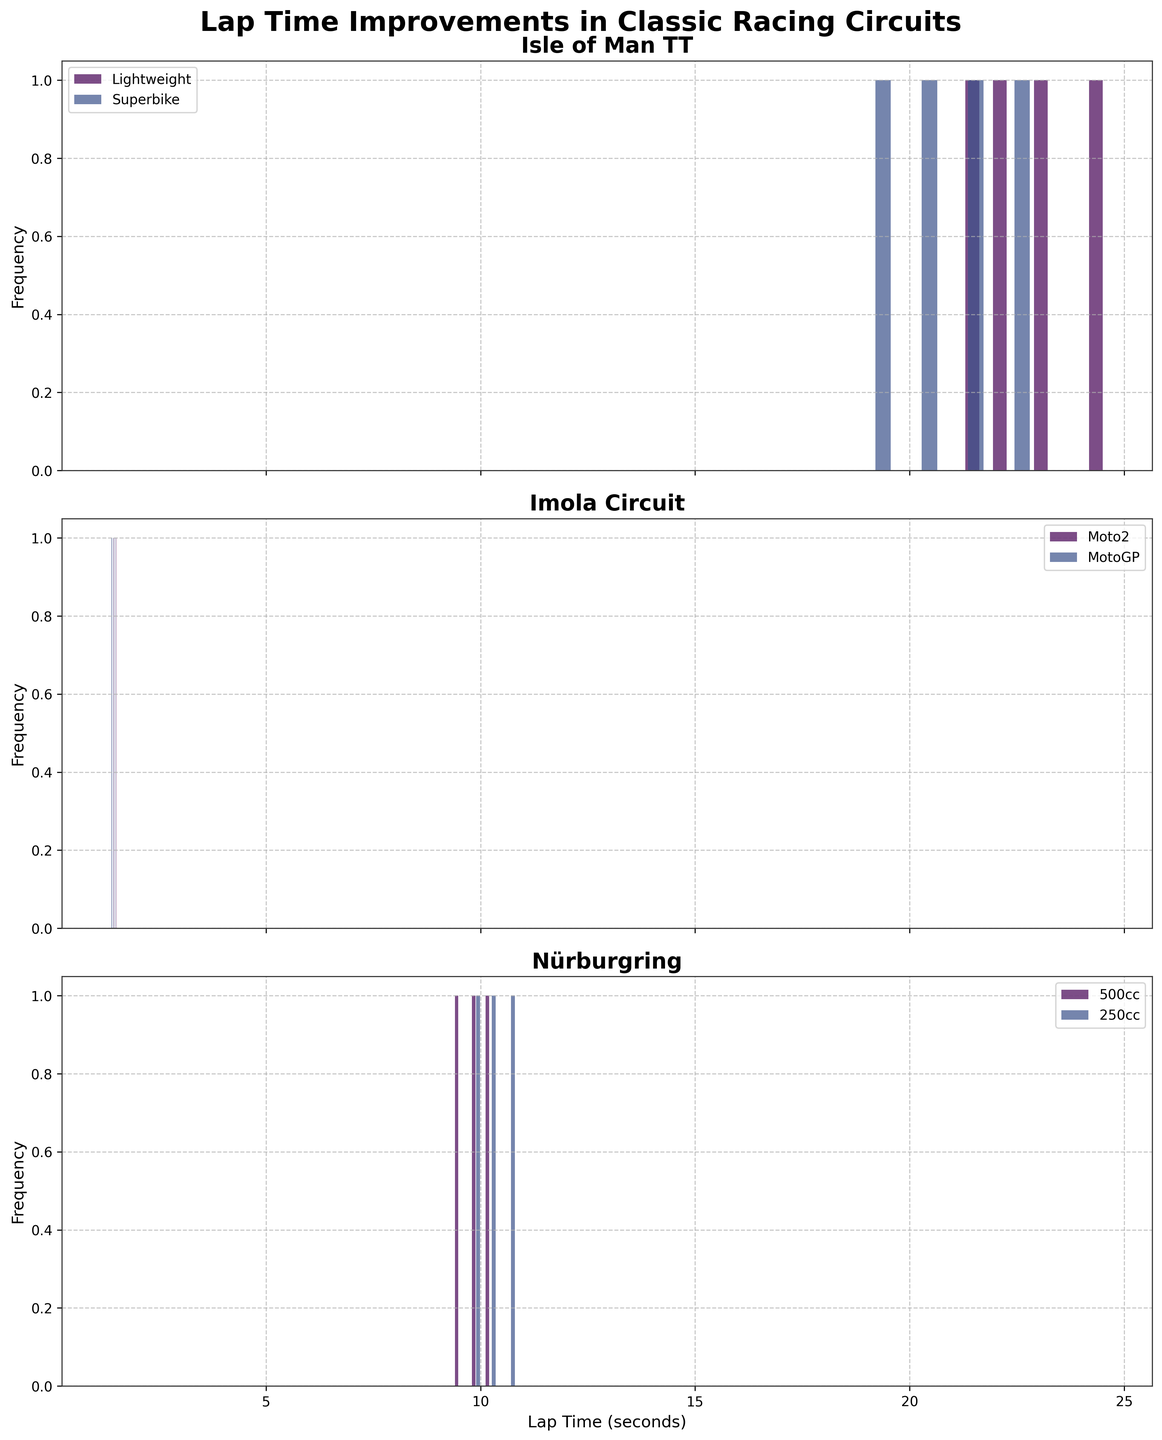What is the title of the figure? The title of the figure is written at the top of the plot. It reads "Lap Time Improvements in Classic Racing Circuits."
Answer: Lap Time Improvements in Classic Racing Circuits How many subplots are there in the figure? The number of subplots can be identified by counting the individual sections or panels within the figure. The data suggests there are three unique circuits, so there should be three subplots.
Answer: 3 Which class has the fastest lap time in the Isle of Man TT circuit? To find the fastest lap time for the Isle of Man TT circuit, look through the histogram for the smallest value on the x-axis. For the Isle of Man TT subplot, the Superbike class shows the fastest lap time.
Answer: Superbike Which circuit has the most classes represented in the subplot? This can be determined by checking how many unique classes are present in each subplot. The Isle of Man TT plot has Lightweight and Superbike, Imola Circuit has Moto2 and MotoGP, while Nürburgring has 500cc and 250cc. They all have two classes each.
Answer: All circuits have 2 classes What is the range of years depicted in the Isle of Man TT circuit? Review the x-axis labels and the bins in the histogram to find the range of years. For the Isle of Man TT circuit, the years range from 1960 to 1990.
Answer: 1960 to 1990 Which class in the Imola Circuit had the greatest improvement in lap times? Compare the differences in lap times for each class in the Imola Circuit by checking the spread of the histograms. MotoGP shows a significant improvement as the histogram shifts more to the left over the years.
Answer: MotoGP What's the average lap time improvement for the Nürburgring, 500cc class? Calculate the average improvement: (10.2 - 9.8) + (9.8 - 9.4) = 0.4 + 0.4 = 0.8, then divide by the number of intervals (2), thus 0.8 / 2 = 0.4.
Answer: 0.4 Do any of the classes in Nürburgring show the same lap time in multiple bins? Check the histogram bins for overlapping values. For the Nürburgring classes, there are no repeating lap times visible in the same bins for both 500cc and 250cc classes.
Answer: No Which circuit shows the most consistent lap time improvements across all classes? Determine which circuit has histograms that exhibit a uniform shift to the left, indicating consistent improvement. Both classes in the Isle of Man TT subplot show steady leftward movement over the years.
Answer: Isle of Man TT 